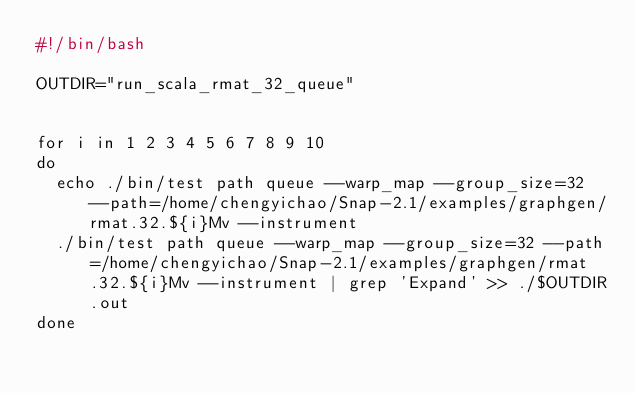Convert code to text. <code><loc_0><loc_0><loc_500><loc_500><_Bash_>#!/bin/bash

OUTDIR="run_scala_rmat_32_queue"


for i in 1 2 3 4 5 6 7 8 9 10
do
	echo ./bin/test path queue --warp_map --group_size=32 --path=/home/chengyichao/Snap-2.1/examples/graphgen/rmat.32.${i}Mv --instrument
	./bin/test path queue --warp_map --group_size=32 --path=/home/chengyichao/Snap-2.1/examples/graphgen/rmat.32.${i}Mv --instrument | grep 'Expand' >> ./$OUTDIR.out
done</code> 